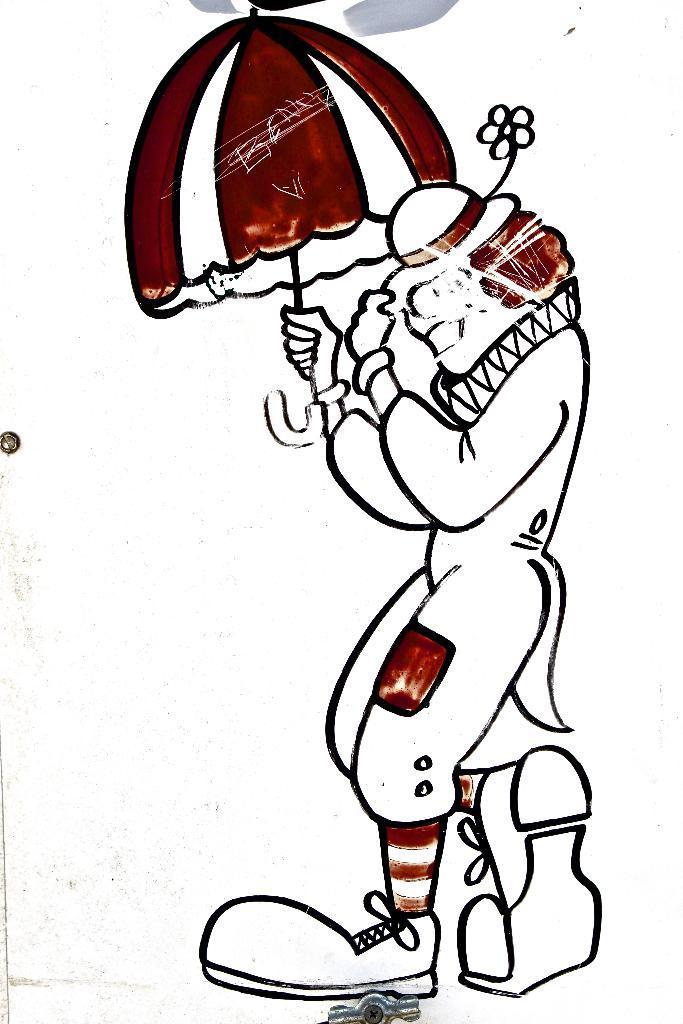Could you give a brief overview of what you see in this image? In the picture we can see a painting of the cartoon person standing with an umbrella. 